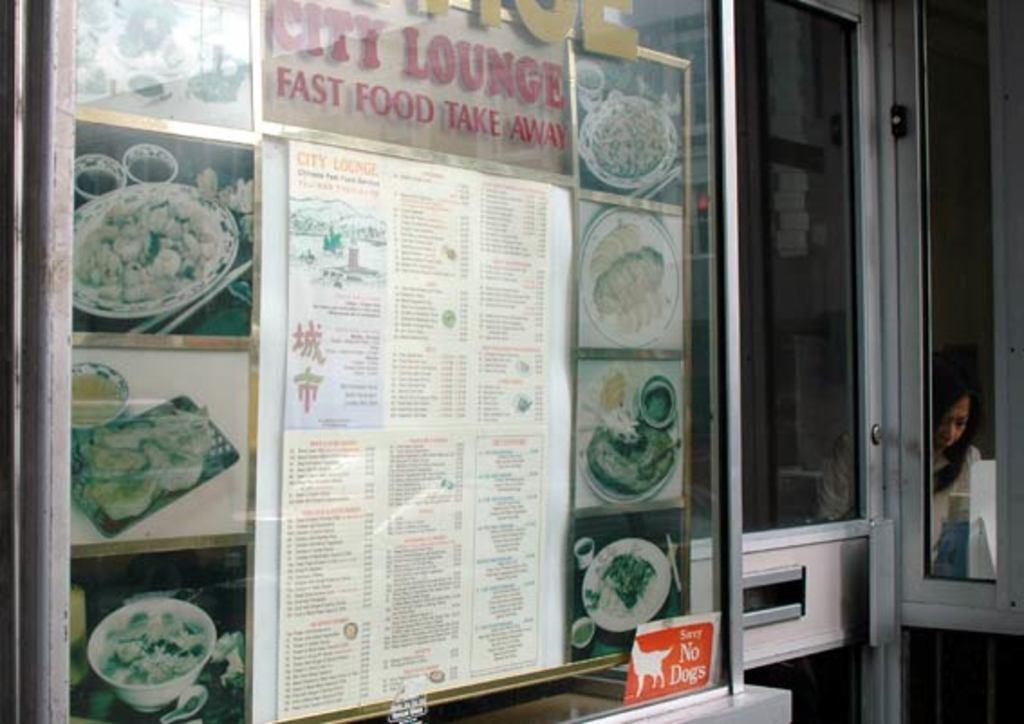What sort of lounge?
Offer a terse response. City. What speed of food?
Provide a short and direct response. Fast. 